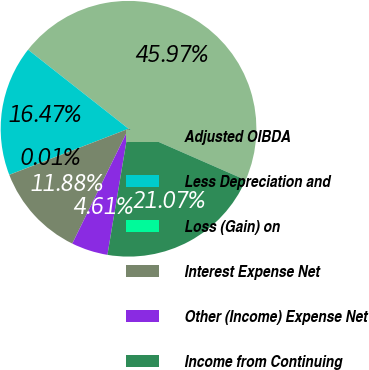Convert chart. <chart><loc_0><loc_0><loc_500><loc_500><pie_chart><fcel>Adjusted OIBDA<fcel>Less Depreciation and<fcel>Loss (Gain) on<fcel>Interest Expense Net<fcel>Other (Income) Expense Net<fcel>Income from Continuing<nl><fcel>45.97%<fcel>16.47%<fcel>0.01%<fcel>11.88%<fcel>4.61%<fcel>21.07%<nl></chart> 